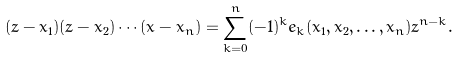<formula> <loc_0><loc_0><loc_500><loc_500>( z - x _ { 1 } ) ( z - x _ { 2 } ) \cdots ( x - x _ { n } ) = \sum _ { k = 0 } ^ { n } ( - 1 ) ^ { k } e _ { k } ( x _ { 1 } , x _ { 2 } , \dots , x _ { n } ) z ^ { n - k } .</formula> 